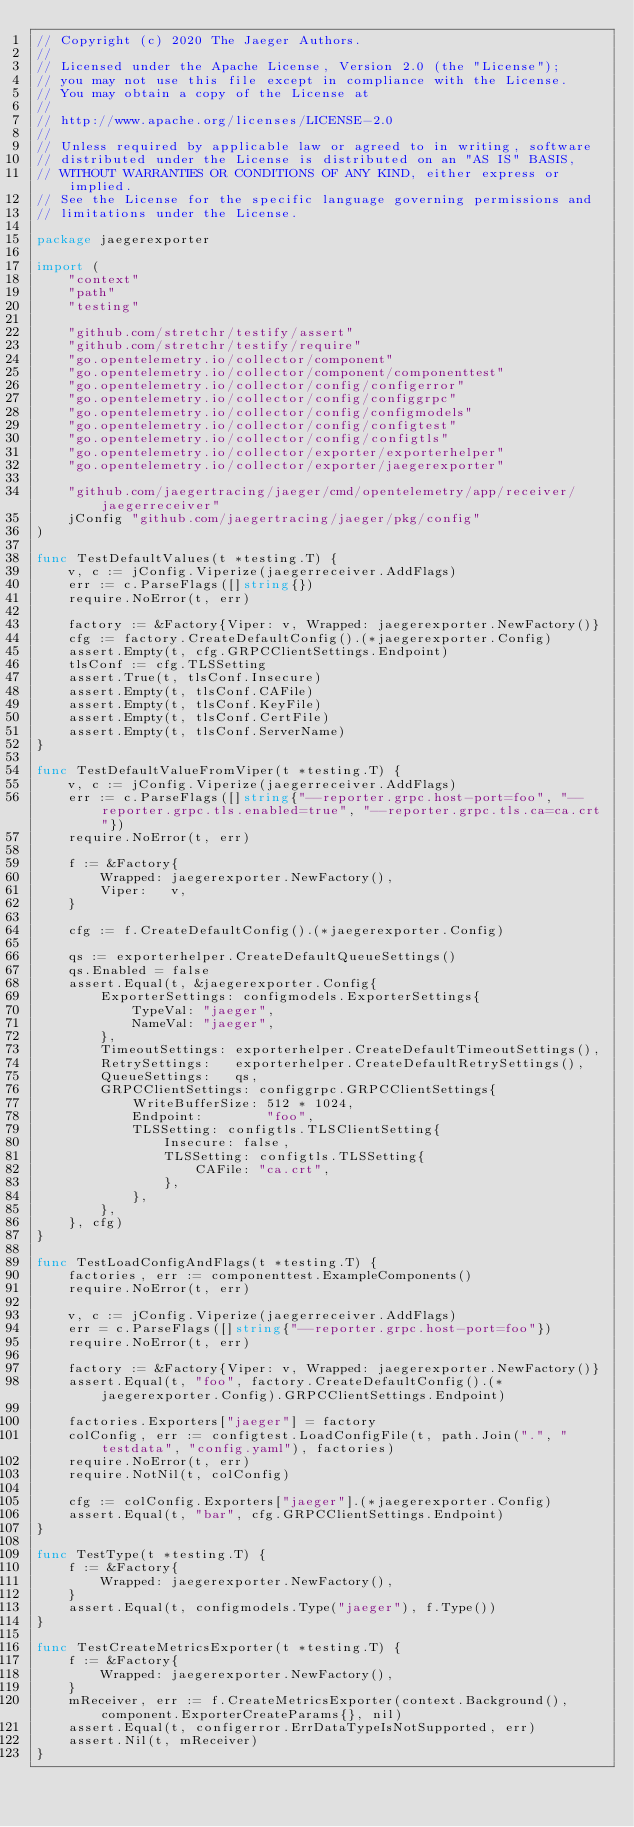<code> <loc_0><loc_0><loc_500><loc_500><_Go_>// Copyright (c) 2020 The Jaeger Authors.
//
// Licensed under the Apache License, Version 2.0 (the "License");
// you may not use this file except in compliance with the License.
// You may obtain a copy of the License at
//
// http://www.apache.org/licenses/LICENSE-2.0
//
// Unless required by applicable law or agreed to in writing, software
// distributed under the License is distributed on an "AS IS" BASIS,
// WITHOUT WARRANTIES OR CONDITIONS OF ANY KIND, either express or implied.
// See the License for the specific language governing permissions and
// limitations under the License.

package jaegerexporter

import (
	"context"
	"path"
	"testing"

	"github.com/stretchr/testify/assert"
	"github.com/stretchr/testify/require"
	"go.opentelemetry.io/collector/component"
	"go.opentelemetry.io/collector/component/componenttest"
	"go.opentelemetry.io/collector/config/configerror"
	"go.opentelemetry.io/collector/config/configgrpc"
	"go.opentelemetry.io/collector/config/configmodels"
	"go.opentelemetry.io/collector/config/configtest"
	"go.opentelemetry.io/collector/config/configtls"
	"go.opentelemetry.io/collector/exporter/exporterhelper"
	"go.opentelemetry.io/collector/exporter/jaegerexporter"

	"github.com/jaegertracing/jaeger/cmd/opentelemetry/app/receiver/jaegerreceiver"
	jConfig "github.com/jaegertracing/jaeger/pkg/config"
)

func TestDefaultValues(t *testing.T) {
	v, c := jConfig.Viperize(jaegerreceiver.AddFlags)
	err := c.ParseFlags([]string{})
	require.NoError(t, err)

	factory := &Factory{Viper: v, Wrapped: jaegerexporter.NewFactory()}
	cfg := factory.CreateDefaultConfig().(*jaegerexporter.Config)
	assert.Empty(t, cfg.GRPCClientSettings.Endpoint)
	tlsConf := cfg.TLSSetting
	assert.True(t, tlsConf.Insecure)
	assert.Empty(t, tlsConf.CAFile)
	assert.Empty(t, tlsConf.KeyFile)
	assert.Empty(t, tlsConf.CertFile)
	assert.Empty(t, tlsConf.ServerName)
}

func TestDefaultValueFromViper(t *testing.T) {
	v, c := jConfig.Viperize(jaegerreceiver.AddFlags)
	err := c.ParseFlags([]string{"--reporter.grpc.host-port=foo", "--reporter.grpc.tls.enabled=true", "--reporter.grpc.tls.ca=ca.crt"})
	require.NoError(t, err)

	f := &Factory{
		Wrapped: jaegerexporter.NewFactory(),
		Viper:   v,
	}

	cfg := f.CreateDefaultConfig().(*jaegerexporter.Config)

	qs := exporterhelper.CreateDefaultQueueSettings()
	qs.Enabled = false
	assert.Equal(t, &jaegerexporter.Config{
		ExporterSettings: configmodels.ExporterSettings{
			TypeVal: "jaeger",
			NameVal: "jaeger",
		},
		TimeoutSettings: exporterhelper.CreateDefaultTimeoutSettings(),
		RetrySettings:   exporterhelper.CreateDefaultRetrySettings(),
		QueueSettings:   qs,
		GRPCClientSettings: configgrpc.GRPCClientSettings{
			WriteBufferSize: 512 * 1024,
			Endpoint:        "foo",
			TLSSetting: configtls.TLSClientSetting{
				Insecure: false,
				TLSSetting: configtls.TLSSetting{
					CAFile: "ca.crt",
				},
			},
		},
	}, cfg)
}

func TestLoadConfigAndFlags(t *testing.T) {
	factories, err := componenttest.ExampleComponents()
	require.NoError(t, err)

	v, c := jConfig.Viperize(jaegerreceiver.AddFlags)
	err = c.ParseFlags([]string{"--reporter.grpc.host-port=foo"})
	require.NoError(t, err)

	factory := &Factory{Viper: v, Wrapped: jaegerexporter.NewFactory()}
	assert.Equal(t, "foo", factory.CreateDefaultConfig().(*jaegerexporter.Config).GRPCClientSettings.Endpoint)

	factories.Exporters["jaeger"] = factory
	colConfig, err := configtest.LoadConfigFile(t, path.Join(".", "testdata", "config.yaml"), factories)
	require.NoError(t, err)
	require.NotNil(t, colConfig)

	cfg := colConfig.Exporters["jaeger"].(*jaegerexporter.Config)
	assert.Equal(t, "bar", cfg.GRPCClientSettings.Endpoint)
}

func TestType(t *testing.T) {
	f := &Factory{
		Wrapped: jaegerexporter.NewFactory(),
	}
	assert.Equal(t, configmodels.Type("jaeger"), f.Type())
}

func TestCreateMetricsExporter(t *testing.T) {
	f := &Factory{
		Wrapped: jaegerexporter.NewFactory(),
	}
	mReceiver, err := f.CreateMetricsExporter(context.Background(), component.ExporterCreateParams{}, nil)
	assert.Equal(t, configerror.ErrDataTypeIsNotSupported, err)
	assert.Nil(t, mReceiver)
}
</code> 